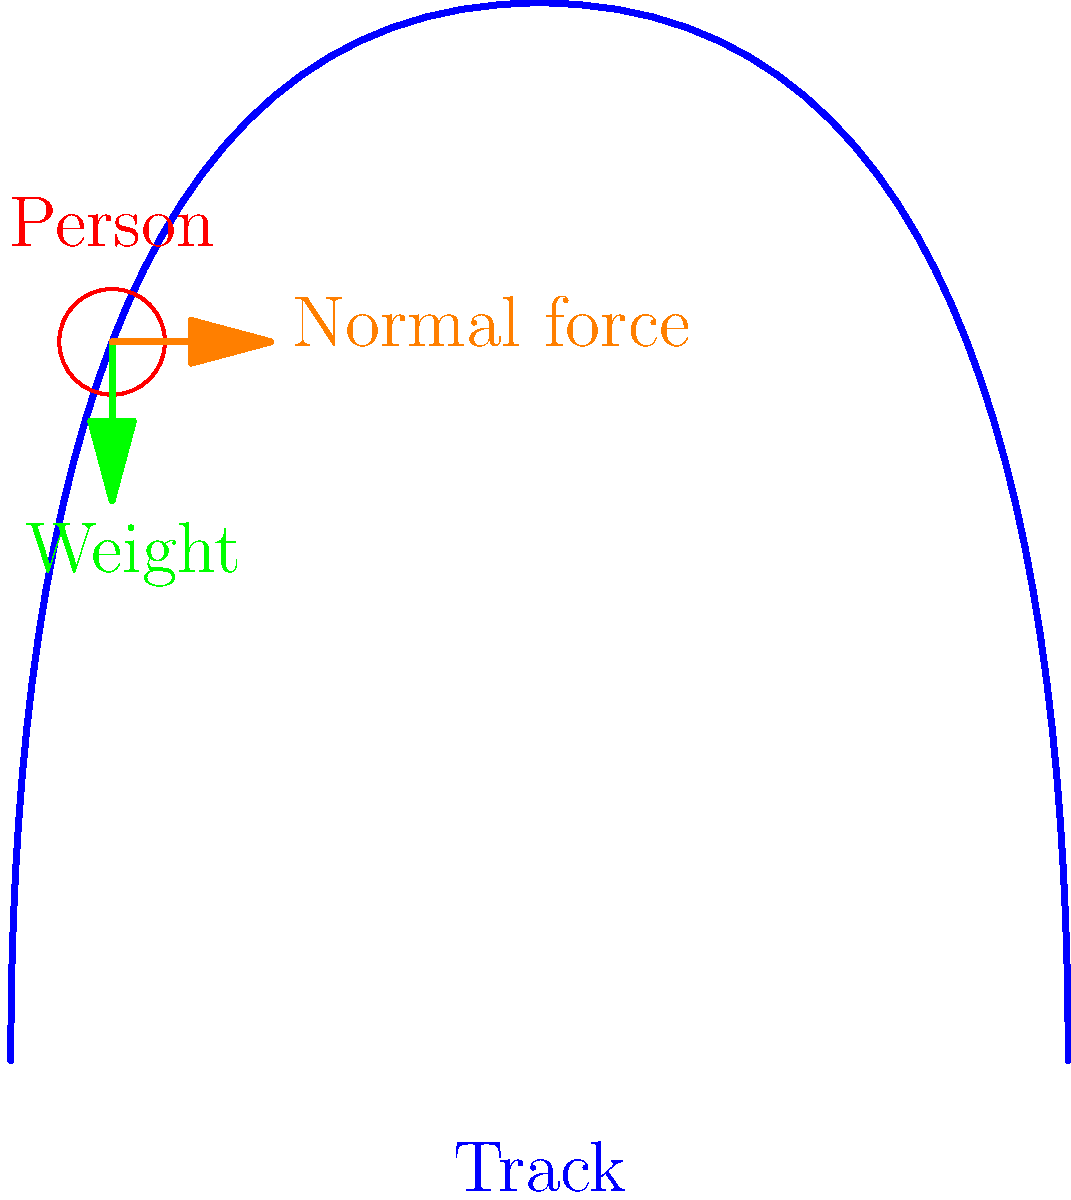Remember that field trip to the amusement park during high school physics class? Consider a person riding a roller coaster at the point shown in the diagram. If the person has a mass of 70 kg and is moving at a constant speed of 20 m/s at this point, what is the magnitude of the normal force exerted by the track on the person? Assume $g = 9.8$ m/s² and that the radius of curvature at this point is 25 m. Let's approach this step-by-step:

1) First, we need to identify the forces acting on the person. There are two main forces:
   - The weight of the person (downward)
   - The normal force from the track (perpendicular to the track)

2) The weight of the person is given by:
   $W = mg = 70 \text{ kg} \times 9.8 \text{ m/s}^2 = 686 \text{ N}$

3) Since the person is moving in a circular path at this point, there's a centripetal acceleration involved. The centripetal acceleration is given by:
   $a_c = \frac{v^2}{r}$
   Where $v$ is the velocity and $r$ is the radius of curvature.

4) Calculating the centripetal acceleration:
   $a_c = \frac{(20 \text{ m/s})^2}{25 \text{ m}} = 16 \text{ m/s}^2$

5) The net force causing this acceleration is the difference between the normal force and the component of weight perpendicular to the track. We can write:
   $F_{net} = N - W\cos\theta = ma_c$
   Where $\theta$ is the angle of the track at this point.

6) We don't know $\theta$, but we can use the fact that the component of the normal force parallel to weight must equal the weight:
   $N\sin\theta = W = 686 \text{ N}$

7) Using the Pythagorean theorem:
   $N^2 = (N\sin\theta)^2 + (N\cos\theta)^2$
   $N^2 = W^2 + (ma_c)^2$

8) Substituting the values:
   $N^2 = (686 \text{ N})^2 + (70 \text{ kg} \times 16 \text{ m/s}^2)^2$
   $N^2 = 470,596 \text{ N}^2 + 1,254,400 \text{ N}^2 = 1,724,996 \text{ N}^2$

9) Taking the square root:
   $N = \sqrt{1,724,996} = 1,313.4 \text{ N}$

Therefore, the magnitude of the normal force is approximately 1,313 N.
Answer: 1,313 N 